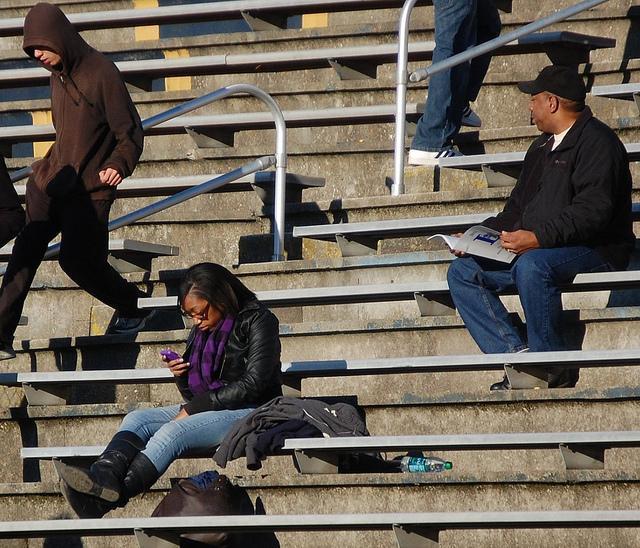How many people are in the picture?
Give a very brief answer. 4. 